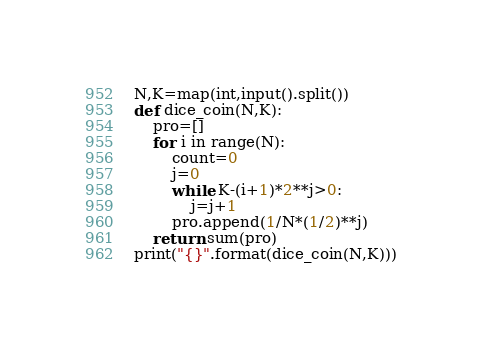Convert code to text. <code><loc_0><loc_0><loc_500><loc_500><_Python_>N,K=map(int,input().split())
def dice_coin(N,K):
    pro=[]
    for i in range(N):
        count=0
        j=0
        while K-(i+1)*2**j>0:
            j=j+1
        pro.append(1/N*(1/2)**j)
    return sum(pro)
print("{}".format(dice_coin(N,K)))</code> 